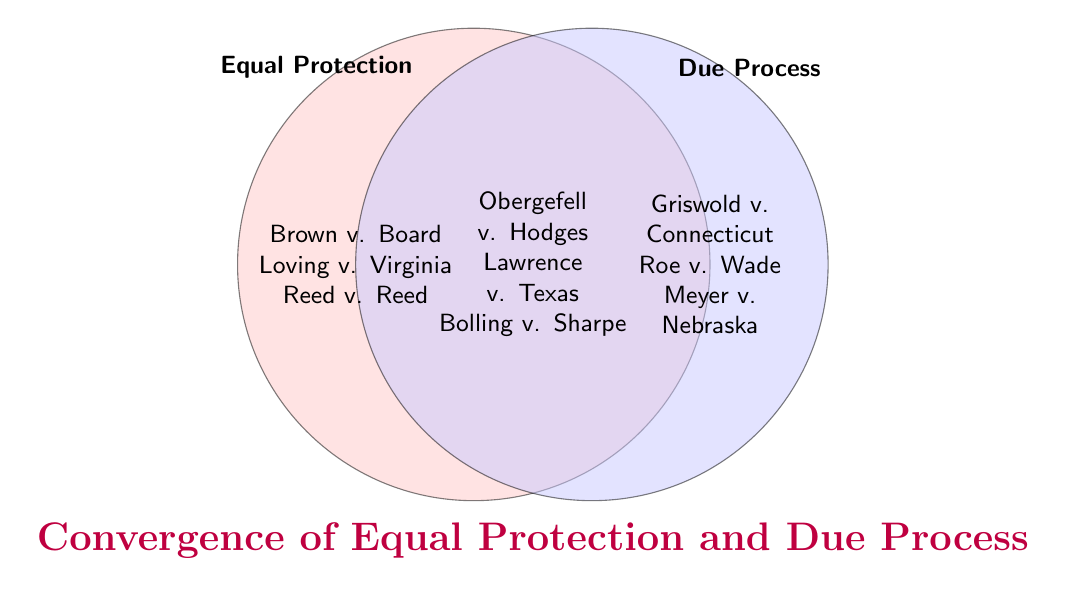Which landmark cases fall under both Equal Protection and Due Process? The intersection of the sets usually represents common elements between two categories. Here, Obergefell v. Hodges, Lawrence v. Texas, and Bolling v. Sharpe are in both categories.
Answer: Obergefell v. Hodges, Lawrence v. Texas, and Bolling v. Sharpe How many cases are uniquely related to Equal Protection but not Due Process? The left circle (Equal Protection) lists cases that are uniquely related to it. Count the items there: Brown v. Board of Education, Loving v. Virginia, Reed v. Reed, Craig v. Boren, and United States v. Virginia.
Answer: 5 Which category does the case Griswold v. Connecticut belong to? Griswold v. Connecticut is listed in the right circle, which represents Due Process.
Answer: Due Process How many total cases are represented in the Venn diagram? Sum the cases in each section: Equal Protection (5), Due Process (5), and the Intersection (3). Thus, 5 + 5 + 3 = 13.
Answer: 13 Are there any cases fully unique to Due Process that are not shared with Equal Protection? The unique Due Process cases are in the right circle and not in the intersection: Griswold v. Connecticut, Roe v. Wade, Meyer v. Nebraska, Pierce v. Society of Sisters, and Skinner v. Oklahoma.
Answer: Yes Which landmark case is included in both categories and deals with LGBTQ+ rights? Obergefell v. Hodges, which falls under the intersection of Equal Protection and Due Process.
Answer: Obergefell v. Hodges Comparing the two sets, which one has the most unique cases? Count the unique cases in each set. Equal Protection has 5 unique cases, and Due Process has 5 unique cases; thus, both have the same number of unique cases.
Answer: Both are equal What is the title of the Venn diagram? The title is often placed near the top of graphical representations, and here it is labeled below the diagram: Convergence of Equal Protection and Due Process.
Answer: Convergence of Equal Protection and Due Process 